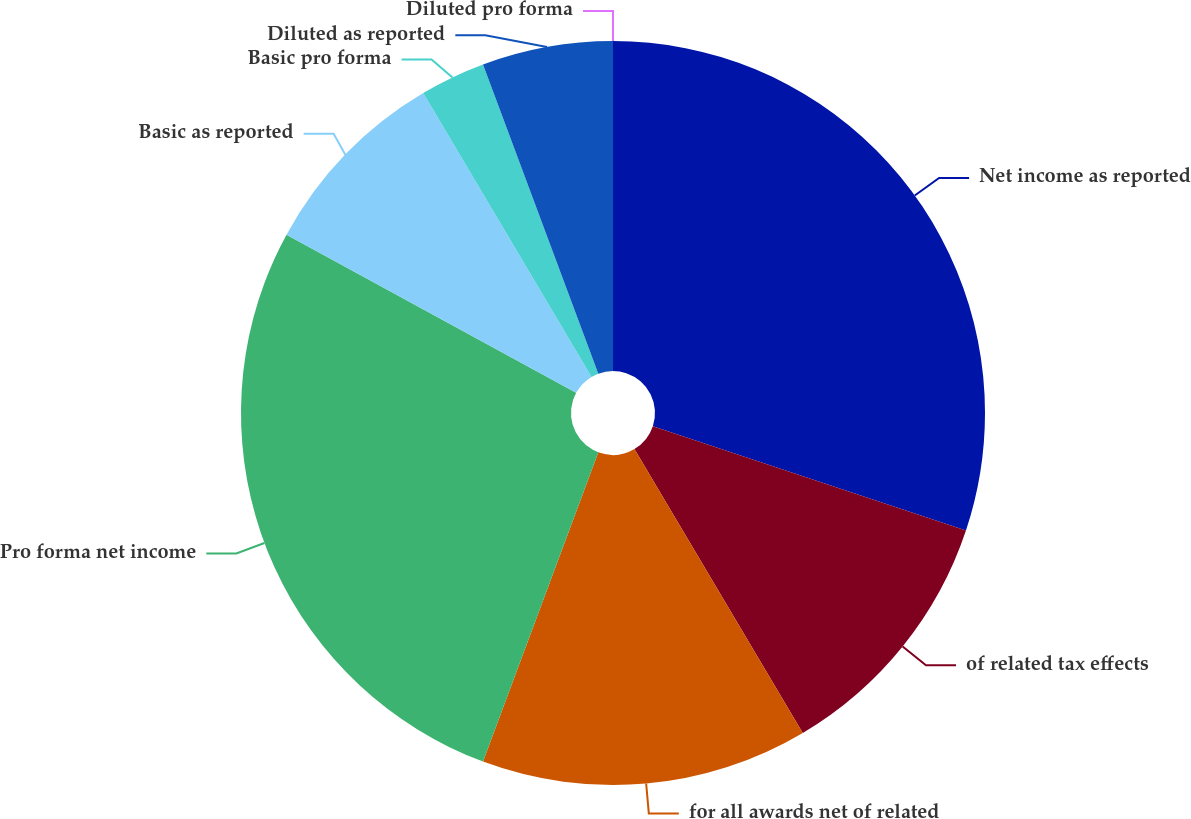Convert chart. <chart><loc_0><loc_0><loc_500><loc_500><pie_chart><fcel>Net income as reported<fcel>of related tax effects<fcel>for all awards net of related<fcel>Pro forma net income<fcel>Basic as reported<fcel>Basic pro forma<fcel>Diluted as reported<fcel>Diluted pro forma<nl><fcel>30.11%<fcel>11.36%<fcel>14.2%<fcel>27.27%<fcel>8.52%<fcel>2.84%<fcel>5.68%<fcel>0.0%<nl></chart> 